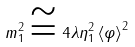Convert formula to latex. <formula><loc_0><loc_0><loc_500><loc_500>m _ { 1 } ^ { 2 } \cong 4 \lambda \eta _ { 1 } ^ { 2 } \left \langle \varphi \right \rangle ^ { 2 }</formula> 